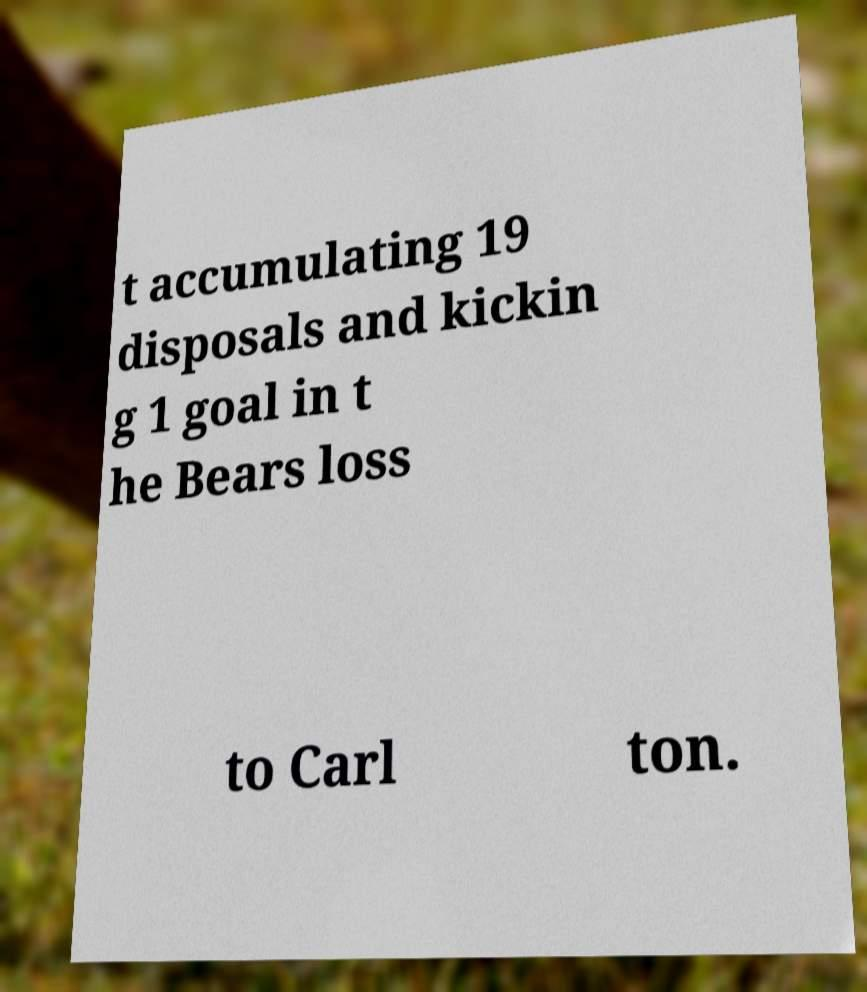Could you assist in decoding the text presented in this image and type it out clearly? t accumulating 19 disposals and kickin g 1 goal in t he Bears loss to Carl ton. 